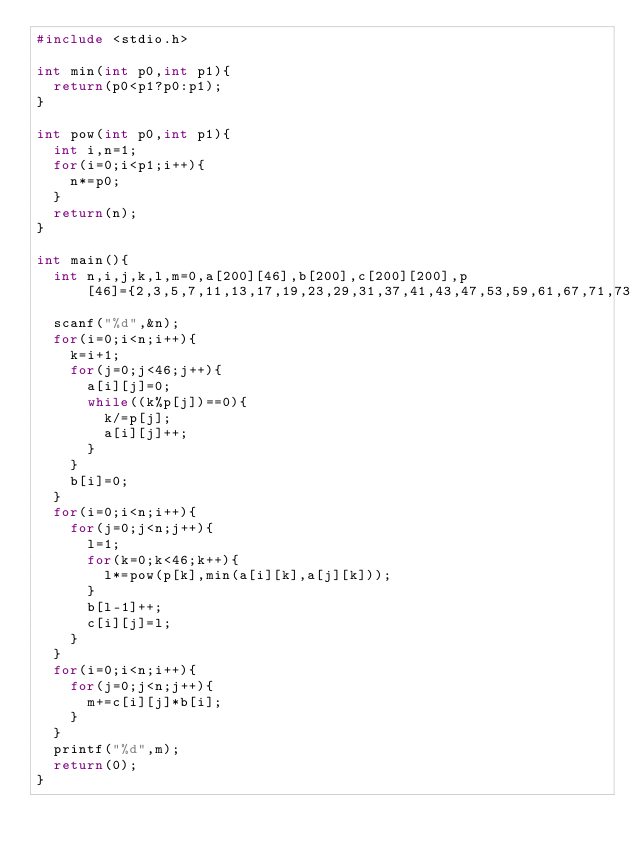Convert code to text. <code><loc_0><loc_0><loc_500><loc_500><_C_>#include <stdio.h>

int min(int p0,int p1){
  return(p0<p1?p0:p1);
}

int pow(int p0,int p1){
  int i,n=1;
  for(i=0;i<p1;i++){
    n*=p0;
  }
  return(n);
}

int main(){
  int n,i,j,k,l,m=0,a[200][46],b[200],c[200][200],p[46]={2,3,5,7,11,13,17,19,23,29,31,37,41,43,47,53,59,61,67,71,73,79,83,89,97,101,103,107,109,113,127,131,137,139,149,151,157,163,167,173,179,181,191,193,197,199};
  scanf("%d",&n);
  for(i=0;i<n;i++){
    k=i+1;
    for(j=0;j<46;j++){
      a[i][j]=0;
      while((k%p[j])==0){
        k/=p[j];
        a[i][j]++;
      }
    }
    b[i]=0;
  }
  for(i=0;i<n;i++){
    for(j=0;j<n;j++){
      l=1;
      for(k=0;k<46;k++){
        l*=pow(p[k],min(a[i][k],a[j][k]));
      }
      b[l-1]++;
      c[i][j]=l;
    }
  }
  for(i=0;i<n;i++){
    for(j=0;j<n;j++){
      m+=c[i][j]*b[i];
    }
  }
  printf("%d",m);
  return(0);
}</code> 